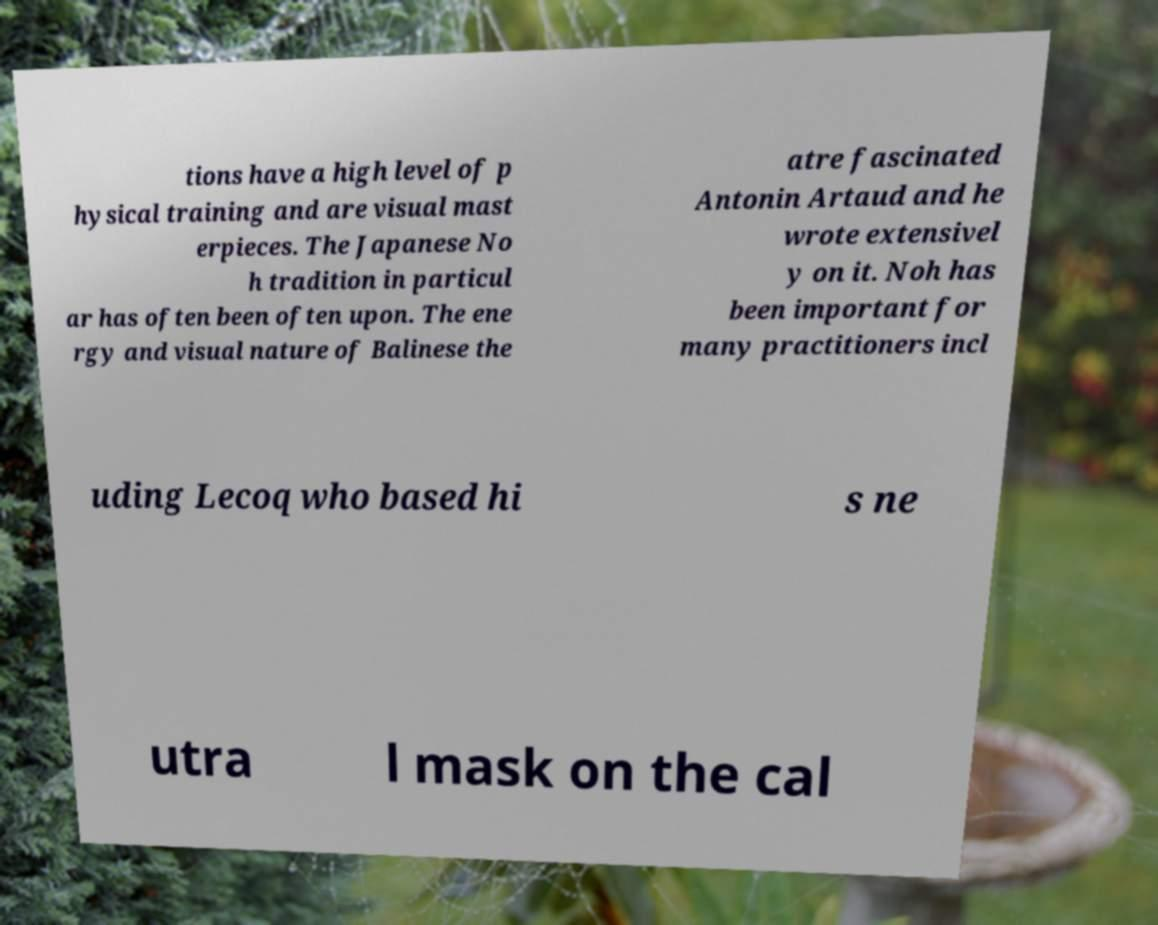Please identify and transcribe the text found in this image. tions have a high level of p hysical training and are visual mast erpieces. The Japanese No h tradition in particul ar has often been often upon. The ene rgy and visual nature of Balinese the atre fascinated Antonin Artaud and he wrote extensivel y on it. Noh has been important for many practitioners incl uding Lecoq who based hi s ne utra l mask on the cal 